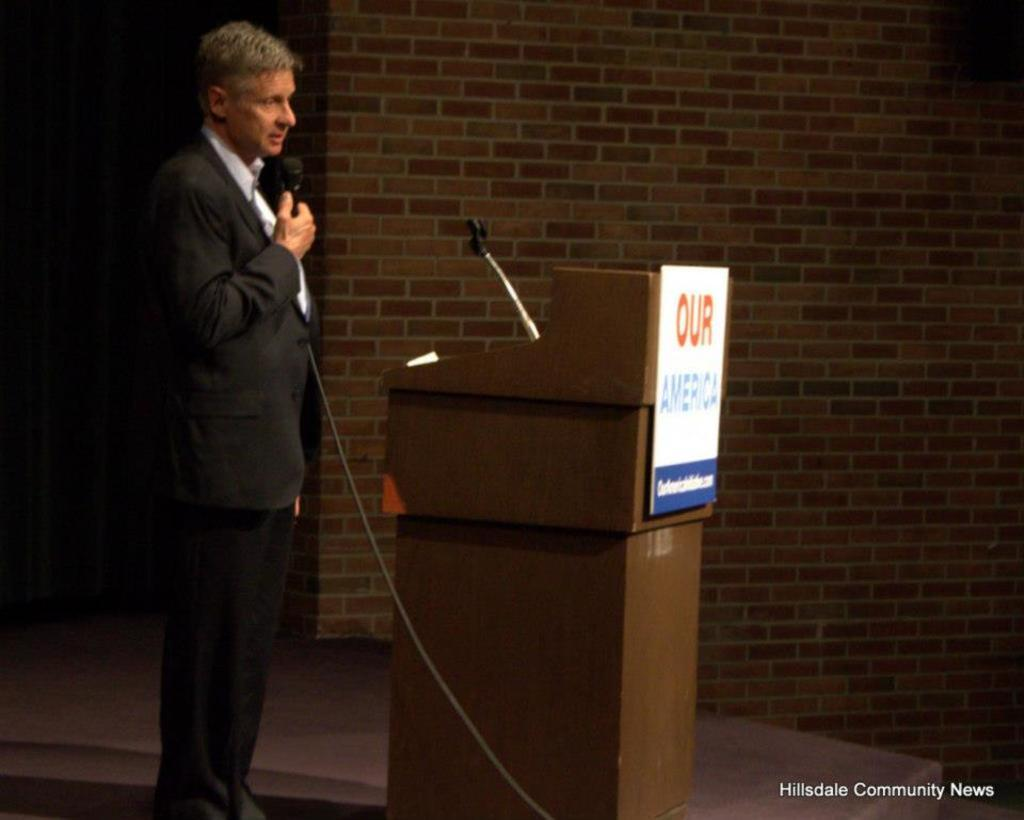Provide a one-sentence caption for the provided image. a man at a microphone with an Our America sign next to him. 